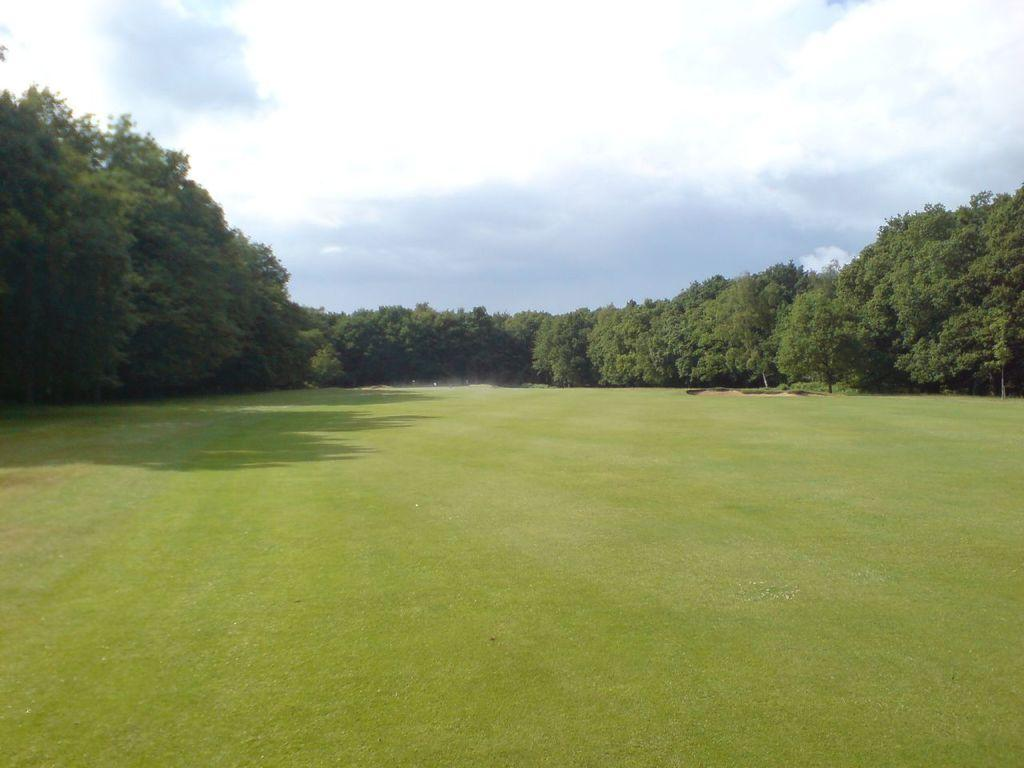What type of vegetation can be seen in the image? There is a group of trees in the image. What is the ground surface like in the image? There is a grass field in the image. What can be seen in the background of the image? The sky is visible in the background of the image. How would you describe the sky in the image? The sky appears to be cloudy. Where is the dock located in the image? There is no dock present in the image. What type of lumber is being used to build the trees in the image? Trees are living organisms and do not require lumber for construction. 